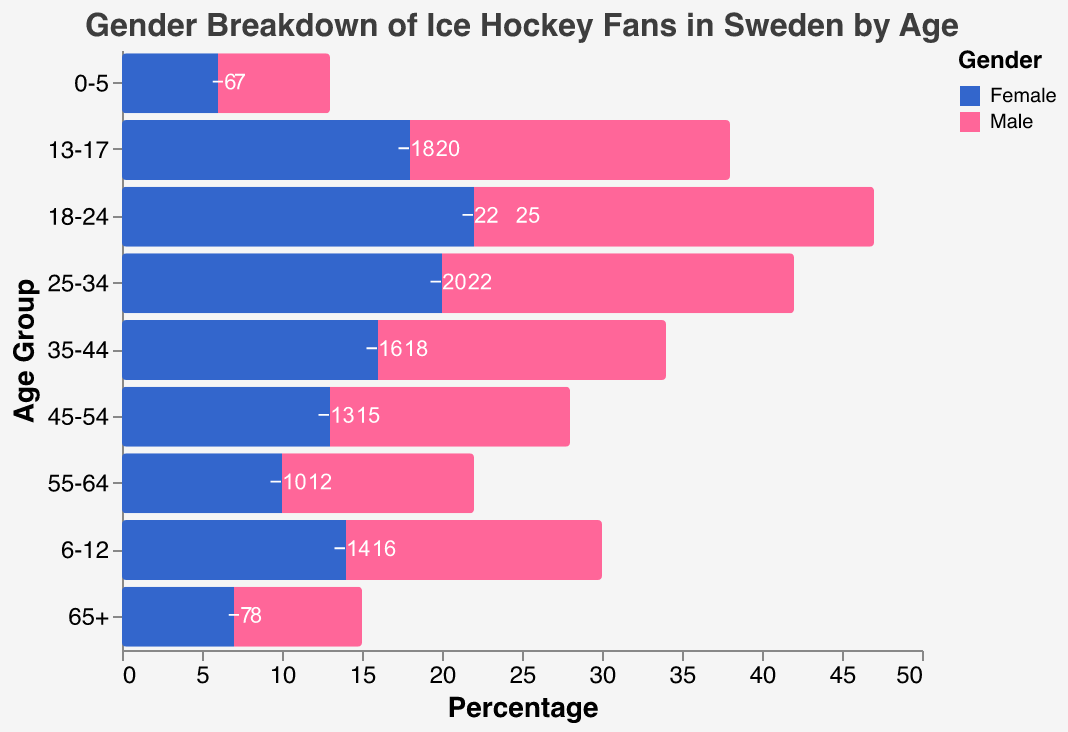What is the title of the figure? The title can be found at the top of the chart. It reads "Gender Breakdown of Ice Hockey Fans in Sweden by Age".
Answer: Gender Breakdown of Ice Hockey Fans in Sweden by Age Which age group has the highest percentage of male ice hockey fans? By examining the lengths of the bars on the male side (right side), the age group with the longest bar is "18-24".
Answer: 18-24 What is the percentage difference between male and female ice hockey fans in the 25-34 age group? The percentage for males is 22 and for females is 20. The difference is calculated as 22 - 20.
Answer: 2 Which gender has a higher percentage of fans in the 45-54 age group? By looking at the direction and length of the bars for the 45-54 age group, the male bar extends further (15) compared to the female bar (-13).
Answer: Male What is the total percentage of ice hockey fans (males and females combined) in the 13-17 age group? Add the absolute values of the percentages for males (20) and females (18): 20 + 18 = 38.
Answer: 38 Compare the percentage of female fans in the 18-24 age group with that of female fans in the 55-64 age group. Which one is higher? The values for female fans are -22 in the 18-24 group and -10 in the 55-64 group. By comparing the absolute values, 22 is higher than 10.
Answer: 18-24 Which age group has the smallest percentage of female ice hockey fans? By examining the lengths of the bars on the female side (left side), the age group with the shortest bar is "0-5" (with -6).
Answer: 0-5 What is the overall trend in the percentage of male ice hockey fans from age group 0-5 to 18-24? Observing the bars from 0-5 to 18-24 on the male side, the percentages increase progressively from 7 to 25.
Answer: Increasing How many age groups have more than 15% female ice hockey fans? Look for bars on the female side with values more negative than -15. The age groups are 25-34 (-20), 18-24 (-22), 13-17 (-18), 6-12 (-14), and 35-44 (-16). We have 5 age groups.
Answer: 5 What is the percentage difference between male and female ice hockey fans in the 65+ age group? The percentage for males is 8 and for females is 7 (consider absolute value). The difference is calculated as 8 - 7.
Answer: 1 